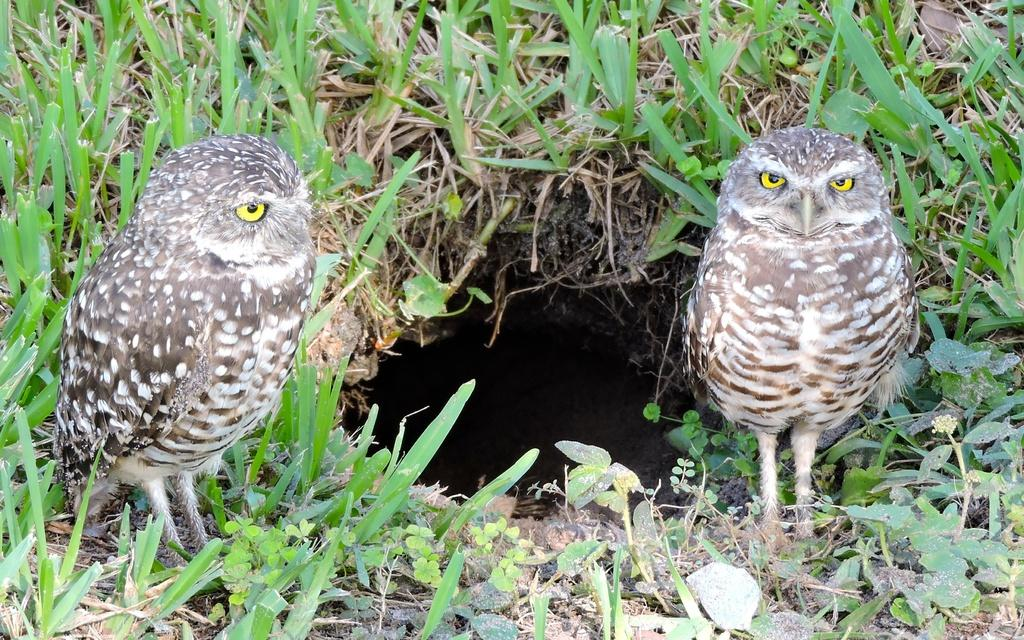What animals can be seen in the foreground of the picture? There are two owls in the foreground of the picture. Where are the owls located? The owls are on the ground. What feature is present on the ground in the image? There is a hole on the ground. What type of vegetation is visible around the hole? Grass is present around the hole. What group of people is responsible for the destruction of the owls' habitat in the image? There is no indication of any destruction or human involvement in the image; it simply shows two owls on the ground with a hole and grass around it. 